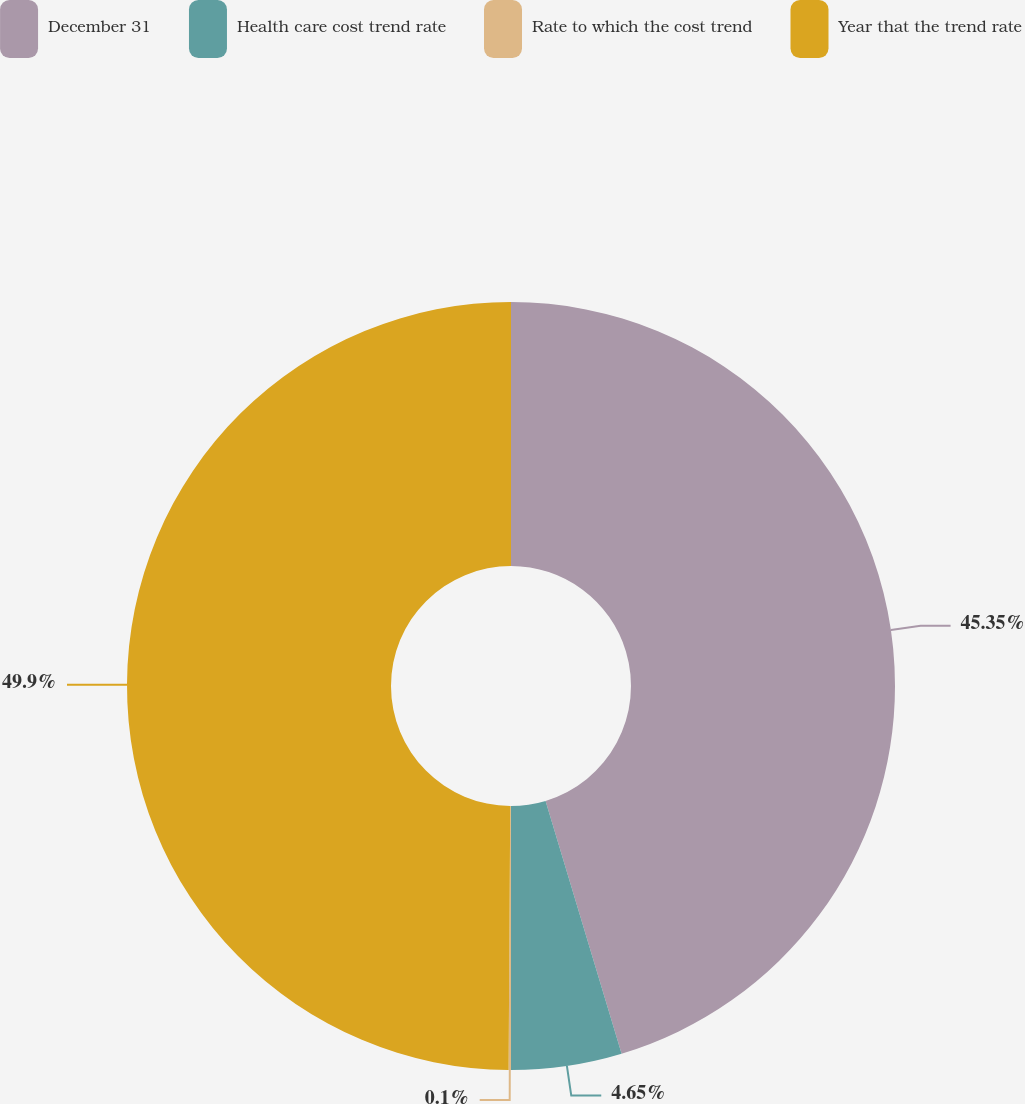<chart> <loc_0><loc_0><loc_500><loc_500><pie_chart><fcel>December 31<fcel>Health care cost trend rate<fcel>Rate to which the cost trend<fcel>Year that the trend rate<nl><fcel>45.35%<fcel>4.65%<fcel>0.1%<fcel>49.9%<nl></chart> 